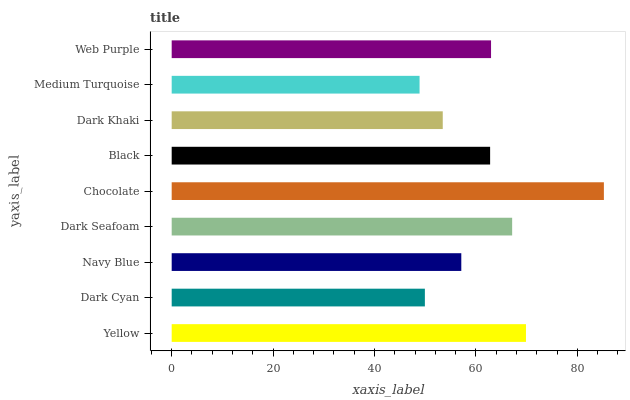Is Medium Turquoise the minimum?
Answer yes or no. Yes. Is Chocolate the maximum?
Answer yes or no. Yes. Is Dark Cyan the minimum?
Answer yes or no. No. Is Dark Cyan the maximum?
Answer yes or no. No. Is Yellow greater than Dark Cyan?
Answer yes or no. Yes. Is Dark Cyan less than Yellow?
Answer yes or no. Yes. Is Dark Cyan greater than Yellow?
Answer yes or no. No. Is Yellow less than Dark Cyan?
Answer yes or no. No. Is Black the high median?
Answer yes or no. Yes. Is Black the low median?
Answer yes or no. Yes. Is Yellow the high median?
Answer yes or no. No. Is Dark Khaki the low median?
Answer yes or no. No. 